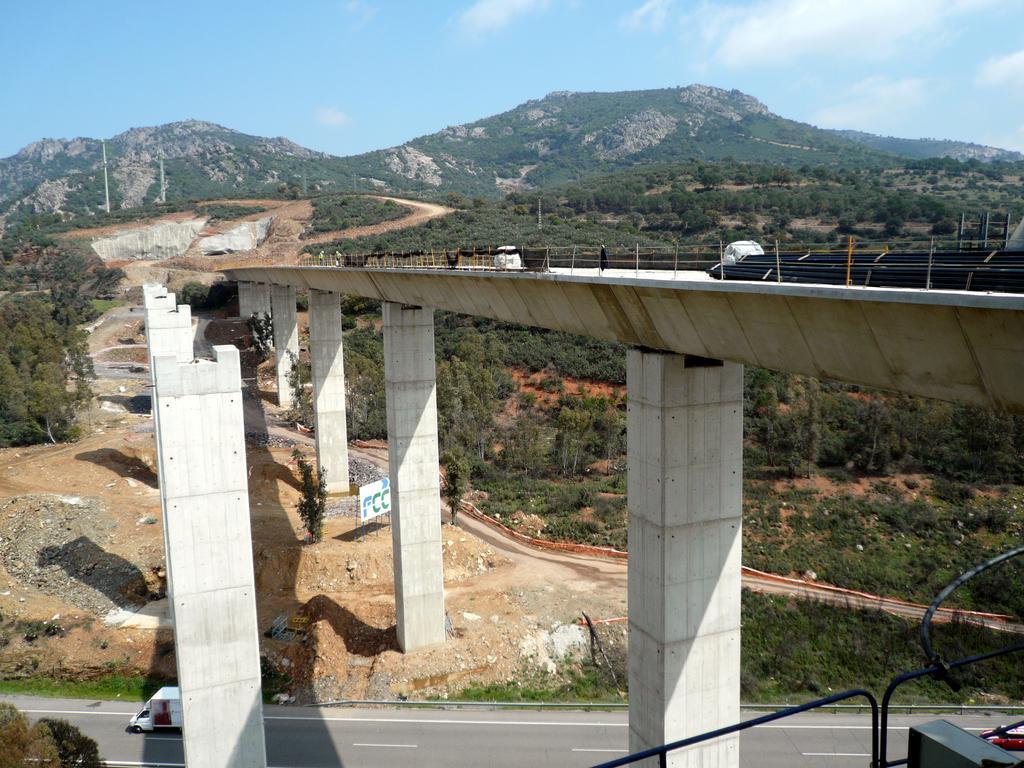Describe this image in one or two sentences. In this image, we can see a bridge. There are pillars on the left side of the image. There is a vehicle on the road which is in between pillars. There are hills in the middle of the image. There is sky at the top of the image. 